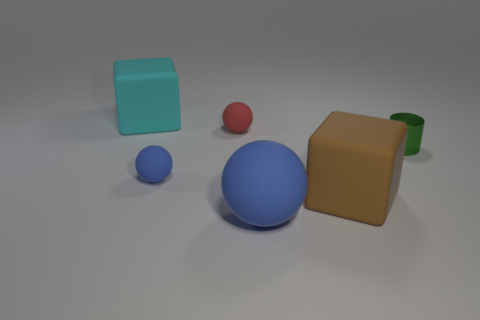Are there any other things that are the same material as the tiny green object?
Ensure brevity in your answer.  No. There is a big thing that is on the left side of the small blue rubber sphere; is it the same shape as the large brown object?
Ensure brevity in your answer.  Yes. How many tiny things are brown rubber cubes or red rubber objects?
Your answer should be very brief. 1. Is the number of tiny blue rubber balls that are to the right of the tiny blue ball the same as the number of big matte objects that are on the right side of the tiny red object?
Your response must be concise. No. What number of other things are the same color as the shiny thing?
Make the answer very short. 0. Does the big matte sphere have the same color as the tiny rubber ball that is in front of the small metallic cylinder?
Offer a very short reply. Yes. What number of red objects are either big rubber blocks or rubber objects?
Provide a short and direct response. 1. Are there the same number of small blue things that are behind the tiny cylinder and blue things?
Your response must be concise. No. What color is the other tiny matte thing that is the same shape as the red object?
Give a very brief answer. Blue. What number of small blue rubber objects have the same shape as the big cyan object?
Offer a very short reply. 0. 